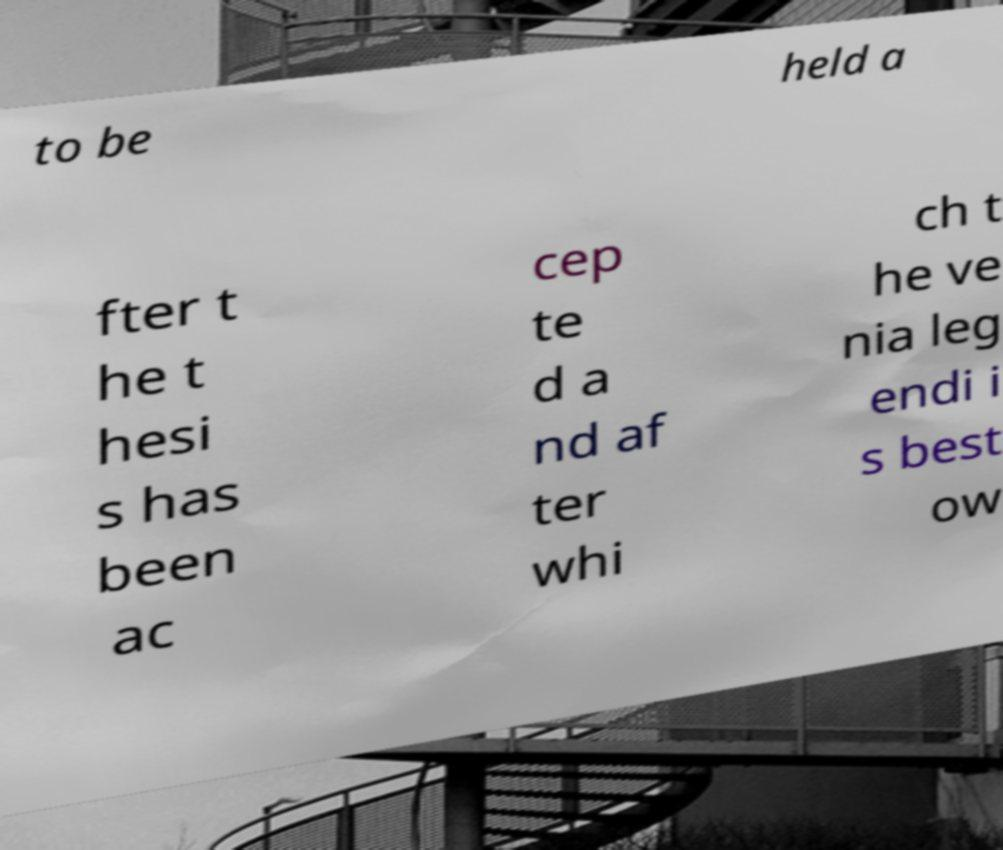There's text embedded in this image that I need extracted. Can you transcribe it verbatim? to be held a fter t he t hesi s has been ac cep te d a nd af ter whi ch t he ve nia leg endi i s best ow 